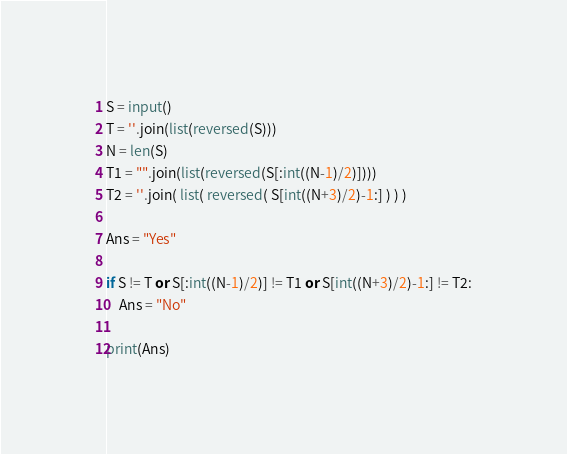Convert code to text. <code><loc_0><loc_0><loc_500><loc_500><_Python_>S = input()
T = ''.join(list(reversed(S)))
N = len(S)
T1 = "".join(list(reversed(S[:int((N-1)/2)])))
T2 = ''.join( list( reversed( S[int((N+3)/2)-1:] ) ) )

Ans = "Yes"

if S != T or S[:int((N-1)/2)] != T1 or S[int((N+3)/2)-1:] != T2:
    Ans = "No"

print(Ans)</code> 